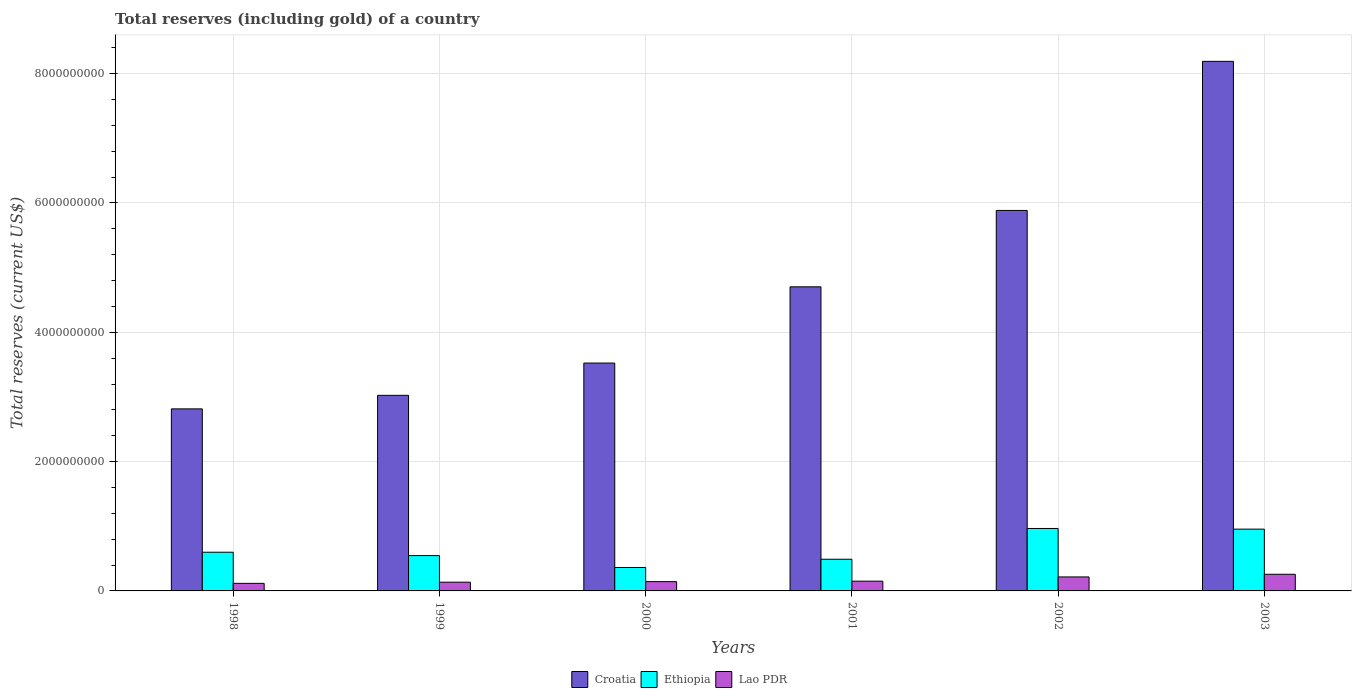How many different coloured bars are there?
Offer a terse response. 3. Are the number of bars per tick equal to the number of legend labels?
Give a very brief answer. Yes. What is the label of the 3rd group of bars from the left?
Give a very brief answer. 2000. What is the total reserves (including gold) in Croatia in 2003?
Your response must be concise. 8.19e+09. Across all years, what is the maximum total reserves (including gold) in Croatia?
Offer a very short reply. 8.19e+09. Across all years, what is the minimum total reserves (including gold) in Lao PDR?
Offer a terse response. 1.17e+08. In which year was the total reserves (including gold) in Lao PDR maximum?
Make the answer very short. 2003. In which year was the total reserves (including gold) in Croatia minimum?
Offer a very short reply. 1998. What is the total total reserves (including gold) in Ethiopia in the graph?
Your answer should be compact. 3.92e+09. What is the difference between the total reserves (including gold) in Croatia in 1999 and that in 2000?
Provide a short and direct response. -4.99e+08. What is the difference between the total reserves (including gold) in Croatia in 2000 and the total reserves (including gold) in Lao PDR in 2002?
Provide a succinct answer. 3.31e+09. What is the average total reserves (including gold) in Croatia per year?
Keep it short and to the point. 4.69e+09. In the year 2002, what is the difference between the total reserves (including gold) in Lao PDR and total reserves (including gold) in Croatia?
Provide a succinct answer. -5.67e+09. In how many years, is the total reserves (including gold) in Lao PDR greater than 3600000000 US$?
Make the answer very short. 0. What is the ratio of the total reserves (including gold) in Croatia in 1999 to that in 2000?
Your answer should be very brief. 0.86. Is the total reserves (including gold) in Croatia in 1999 less than that in 2000?
Offer a very short reply. Yes. Is the difference between the total reserves (including gold) in Lao PDR in 1998 and 2002 greater than the difference between the total reserves (including gold) in Croatia in 1998 and 2002?
Your response must be concise. Yes. What is the difference between the highest and the second highest total reserves (including gold) in Croatia?
Ensure brevity in your answer.  2.31e+09. What is the difference between the highest and the lowest total reserves (including gold) in Lao PDR?
Your response must be concise. 1.40e+08. Is the sum of the total reserves (including gold) in Lao PDR in 2002 and 2003 greater than the maximum total reserves (including gold) in Ethiopia across all years?
Make the answer very short. No. What does the 1st bar from the left in 1999 represents?
Make the answer very short. Croatia. What does the 2nd bar from the right in 1998 represents?
Make the answer very short. Ethiopia. Are all the bars in the graph horizontal?
Provide a short and direct response. No. How many years are there in the graph?
Provide a short and direct response. 6. What is the difference between two consecutive major ticks on the Y-axis?
Your response must be concise. 2.00e+09. Where does the legend appear in the graph?
Provide a succinct answer. Bottom center. How many legend labels are there?
Your answer should be very brief. 3. How are the legend labels stacked?
Keep it short and to the point. Horizontal. What is the title of the graph?
Offer a very short reply. Total reserves (including gold) of a country. What is the label or title of the X-axis?
Make the answer very short. Years. What is the label or title of the Y-axis?
Give a very brief answer. Total reserves (current US$). What is the Total reserves (current US$) in Croatia in 1998?
Give a very brief answer. 2.82e+09. What is the Total reserves (current US$) in Ethiopia in 1998?
Your answer should be very brief. 5.98e+08. What is the Total reserves (current US$) of Lao PDR in 1998?
Keep it short and to the point. 1.17e+08. What is the Total reserves (current US$) of Croatia in 1999?
Your response must be concise. 3.02e+09. What is the Total reserves (current US$) of Ethiopia in 1999?
Provide a succinct answer. 5.47e+08. What is the Total reserves (current US$) of Lao PDR in 1999?
Offer a terse response. 1.35e+08. What is the Total reserves (current US$) of Croatia in 2000?
Provide a short and direct response. 3.52e+09. What is the Total reserves (current US$) of Ethiopia in 2000?
Your answer should be very brief. 3.63e+08. What is the Total reserves (current US$) of Lao PDR in 2000?
Make the answer very short. 1.44e+08. What is the Total reserves (current US$) in Croatia in 2001?
Your answer should be compact. 4.70e+09. What is the Total reserves (current US$) in Ethiopia in 2001?
Keep it short and to the point. 4.90e+08. What is the Total reserves (current US$) of Lao PDR in 2001?
Offer a terse response. 1.51e+08. What is the Total reserves (current US$) of Croatia in 2002?
Offer a very short reply. 5.88e+09. What is the Total reserves (current US$) in Ethiopia in 2002?
Give a very brief answer. 9.66e+08. What is the Total reserves (current US$) in Lao PDR in 2002?
Your response must be concise. 2.16e+08. What is the Total reserves (current US$) of Croatia in 2003?
Provide a short and direct response. 8.19e+09. What is the Total reserves (current US$) of Ethiopia in 2003?
Ensure brevity in your answer.  9.56e+08. What is the Total reserves (current US$) in Lao PDR in 2003?
Keep it short and to the point. 2.57e+08. Across all years, what is the maximum Total reserves (current US$) in Croatia?
Your response must be concise. 8.19e+09. Across all years, what is the maximum Total reserves (current US$) of Ethiopia?
Offer a terse response. 9.66e+08. Across all years, what is the maximum Total reserves (current US$) of Lao PDR?
Provide a short and direct response. 2.57e+08. Across all years, what is the minimum Total reserves (current US$) of Croatia?
Ensure brevity in your answer.  2.82e+09. Across all years, what is the minimum Total reserves (current US$) in Ethiopia?
Your answer should be compact. 3.63e+08. Across all years, what is the minimum Total reserves (current US$) in Lao PDR?
Offer a terse response. 1.17e+08. What is the total Total reserves (current US$) in Croatia in the graph?
Offer a very short reply. 2.81e+1. What is the total Total reserves (current US$) in Ethiopia in the graph?
Provide a succinct answer. 3.92e+09. What is the total Total reserves (current US$) of Lao PDR in the graph?
Your answer should be compact. 1.02e+09. What is the difference between the Total reserves (current US$) of Croatia in 1998 and that in 1999?
Offer a terse response. -2.09e+08. What is the difference between the Total reserves (current US$) of Ethiopia in 1998 and that in 1999?
Your answer should be compact. 5.18e+07. What is the difference between the Total reserves (current US$) of Lao PDR in 1998 and that in 1999?
Your answer should be very brief. -1.80e+07. What is the difference between the Total reserves (current US$) of Croatia in 1998 and that in 2000?
Keep it short and to the point. -7.09e+08. What is the difference between the Total reserves (current US$) in Ethiopia in 1998 and that in 2000?
Provide a short and direct response. 2.36e+08. What is the difference between the Total reserves (current US$) in Lao PDR in 1998 and that in 2000?
Your response must be concise. -2.64e+07. What is the difference between the Total reserves (current US$) of Croatia in 1998 and that in 2001?
Offer a very short reply. -1.89e+09. What is the difference between the Total reserves (current US$) of Ethiopia in 1998 and that in 2001?
Provide a succinct answer. 1.09e+08. What is the difference between the Total reserves (current US$) of Lao PDR in 1998 and that in 2001?
Ensure brevity in your answer.  -3.38e+07. What is the difference between the Total reserves (current US$) of Croatia in 1998 and that in 2002?
Your response must be concise. -3.07e+09. What is the difference between the Total reserves (current US$) in Ethiopia in 1998 and that in 2002?
Make the answer very short. -3.67e+08. What is the difference between the Total reserves (current US$) of Lao PDR in 1998 and that in 2002?
Provide a short and direct response. -9.92e+07. What is the difference between the Total reserves (current US$) in Croatia in 1998 and that in 2003?
Provide a short and direct response. -5.37e+09. What is the difference between the Total reserves (current US$) in Ethiopia in 1998 and that in 2003?
Your answer should be compact. -3.57e+08. What is the difference between the Total reserves (current US$) of Lao PDR in 1998 and that in 2003?
Make the answer very short. -1.40e+08. What is the difference between the Total reserves (current US$) of Croatia in 1999 and that in 2000?
Your answer should be very brief. -4.99e+08. What is the difference between the Total reserves (current US$) of Ethiopia in 1999 and that in 2000?
Offer a very short reply. 1.84e+08. What is the difference between the Total reserves (current US$) in Lao PDR in 1999 and that in 2000?
Offer a very short reply. -8.41e+06. What is the difference between the Total reserves (current US$) in Croatia in 1999 and that in 2001?
Provide a short and direct response. -1.68e+09. What is the difference between the Total reserves (current US$) of Ethiopia in 1999 and that in 2001?
Ensure brevity in your answer.  5.67e+07. What is the difference between the Total reserves (current US$) of Lao PDR in 1999 and that in 2001?
Give a very brief answer. -1.57e+07. What is the difference between the Total reserves (current US$) in Croatia in 1999 and that in 2002?
Offer a very short reply. -2.86e+09. What is the difference between the Total reserves (current US$) of Ethiopia in 1999 and that in 2002?
Ensure brevity in your answer.  -4.19e+08. What is the difference between the Total reserves (current US$) in Lao PDR in 1999 and that in 2002?
Provide a succinct answer. -8.12e+07. What is the difference between the Total reserves (current US$) in Croatia in 1999 and that in 2003?
Offer a very short reply. -5.17e+09. What is the difference between the Total reserves (current US$) of Ethiopia in 1999 and that in 2003?
Keep it short and to the point. -4.09e+08. What is the difference between the Total reserves (current US$) in Lao PDR in 1999 and that in 2003?
Your answer should be very brief. -1.22e+08. What is the difference between the Total reserves (current US$) of Croatia in 2000 and that in 2001?
Your answer should be very brief. -1.18e+09. What is the difference between the Total reserves (current US$) of Ethiopia in 2000 and that in 2001?
Provide a short and direct response. -1.27e+08. What is the difference between the Total reserves (current US$) in Lao PDR in 2000 and that in 2001?
Offer a very short reply. -7.32e+06. What is the difference between the Total reserves (current US$) of Croatia in 2000 and that in 2002?
Your answer should be compact. -2.36e+09. What is the difference between the Total reserves (current US$) in Ethiopia in 2000 and that in 2002?
Provide a succinct answer. -6.03e+08. What is the difference between the Total reserves (current US$) in Lao PDR in 2000 and that in 2002?
Provide a short and direct response. -7.28e+07. What is the difference between the Total reserves (current US$) in Croatia in 2000 and that in 2003?
Your response must be concise. -4.67e+09. What is the difference between the Total reserves (current US$) of Ethiopia in 2000 and that in 2003?
Your answer should be compact. -5.93e+08. What is the difference between the Total reserves (current US$) of Lao PDR in 2000 and that in 2003?
Offer a very short reply. -1.14e+08. What is the difference between the Total reserves (current US$) of Croatia in 2001 and that in 2002?
Your answer should be compact. -1.18e+09. What is the difference between the Total reserves (current US$) in Ethiopia in 2001 and that in 2002?
Make the answer very short. -4.76e+08. What is the difference between the Total reserves (current US$) in Lao PDR in 2001 and that in 2002?
Your response must be concise. -6.54e+07. What is the difference between the Total reserves (current US$) of Croatia in 2001 and that in 2003?
Your response must be concise. -3.49e+09. What is the difference between the Total reserves (current US$) in Ethiopia in 2001 and that in 2003?
Offer a terse response. -4.66e+08. What is the difference between the Total reserves (current US$) of Lao PDR in 2001 and that in 2003?
Keep it short and to the point. -1.07e+08. What is the difference between the Total reserves (current US$) of Croatia in 2002 and that in 2003?
Give a very brief answer. -2.31e+09. What is the difference between the Total reserves (current US$) in Ethiopia in 2002 and that in 2003?
Provide a succinct answer. 1.03e+07. What is the difference between the Total reserves (current US$) in Lao PDR in 2002 and that in 2003?
Give a very brief answer. -4.11e+07. What is the difference between the Total reserves (current US$) of Croatia in 1998 and the Total reserves (current US$) of Ethiopia in 1999?
Your response must be concise. 2.27e+09. What is the difference between the Total reserves (current US$) in Croatia in 1998 and the Total reserves (current US$) in Lao PDR in 1999?
Your answer should be compact. 2.68e+09. What is the difference between the Total reserves (current US$) in Ethiopia in 1998 and the Total reserves (current US$) in Lao PDR in 1999?
Offer a very short reply. 4.63e+08. What is the difference between the Total reserves (current US$) in Croatia in 1998 and the Total reserves (current US$) in Ethiopia in 2000?
Keep it short and to the point. 2.45e+09. What is the difference between the Total reserves (current US$) in Croatia in 1998 and the Total reserves (current US$) in Lao PDR in 2000?
Make the answer very short. 2.67e+09. What is the difference between the Total reserves (current US$) of Ethiopia in 1998 and the Total reserves (current US$) of Lao PDR in 2000?
Give a very brief answer. 4.55e+08. What is the difference between the Total reserves (current US$) in Croatia in 1998 and the Total reserves (current US$) in Ethiopia in 2001?
Your answer should be very brief. 2.33e+09. What is the difference between the Total reserves (current US$) in Croatia in 1998 and the Total reserves (current US$) in Lao PDR in 2001?
Make the answer very short. 2.66e+09. What is the difference between the Total reserves (current US$) of Ethiopia in 1998 and the Total reserves (current US$) of Lao PDR in 2001?
Ensure brevity in your answer.  4.47e+08. What is the difference between the Total reserves (current US$) in Croatia in 1998 and the Total reserves (current US$) in Ethiopia in 2002?
Your answer should be compact. 1.85e+09. What is the difference between the Total reserves (current US$) in Croatia in 1998 and the Total reserves (current US$) in Lao PDR in 2002?
Your response must be concise. 2.60e+09. What is the difference between the Total reserves (current US$) in Ethiopia in 1998 and the Total reserves (current US$) in Lao PDR in 2002?
Offer a terse response. 3.82e+08. What is the difference between the Total reserves (current US$) of Croatia in 1998 and the Total reserves (current US$) of Ethiopia in 2003?
Give a very brief answer. 1.86e+09. What is the difference between the Total reserves (current US$) in Croatia in 1998 and the Total reserves (current US$) in Lao PDR in 2003?
Provide a succinct answer. 2.56e+09. What is the difference between the Total reserves (current US$) in Ethiopia in 1998 and the Total reserves (current US$) in Lao PDR in 2003?
Give a very brief answer. 3.41e+08. What is the difference between the Total reserves (current US$) in Croatia in 1999 and the Total reserves (current US$) in Ethiopia in 2000?
Provide a short and direct response. 2.66e+09. What is the difference between the Total reserves (current US$) in Croatia in 1999 and the Total reserves (current US$) in Lao PDR in 2000?
Ensure brevity in your answer.  2.88e+09. What is the difference between the Total reserves (current US$) of Ethiopia in 1999 and the Total reserves (current US$) of Lao PDR in 2000?
Ensure brevity in your answer.  4.03e+08. What is the difference between the Total reserves (current US$) of Croatia in 1999 and the Total reserves (current US$) of Ethiopia in 2001?
Ensure brevity in your answer.  2.54e+09. What is the difference between the Total reserves (current US$) in Croatia in 1999 and the Total reserves (current US$) in Lao PDR in 2001?
Provide a short and direct response. 2.87e+09. What is the difference between the Total reserves (current US$) in Ethiopia in 1999 and the Total reserves (current US$) in Lao PDR in 2001?
Give a very brief answer. 3.96e+08. What is the difference between the Total reserves (current US$) in Croatia in 1999 and the Total reserves (current US$) in Ethiopia in 2002?
Give a very brief answer. 2.06e+09. What is the difference between the Total reserves (current US$) of Croatia in 1999 and the Total reserves (current US$) of Lao PDR in 2002?
Provide a short and direct response. 2.81e+09. What is the difference between the Total reserves (current US$) of Ethiopia in 1999 and the Total reserves (current US$) of Lao PDR in 2002?
Keep it short and to the point. 3.30e+08. What is the difference between the Total reserves (current US$) of Croatia in 1999 and the Total reserves (current US$) of Ethiopia in 2003?
Your answer should be very brief. 2.07e+09. What is the difference between the Total reserves (current US$) of Croatia in 1999 and the Total reserves (current US$) of Lao PDR in 2003?
Offer a very short reply. 2.77e+09. What is the difference between the Total reserves (current US$) of Ethiopia in 1999 and the Total reserves (current US$) of Lao PDR in 2003?
Give a very brief answer. 2.89e+08. What is the difference between the Total reserves (current US$) in Croatia in 2000 and the Total reserves (current US$) in Ethiopia in 2001?
Your answer should be very brief. 3.03e+09. What is the difference between the Total reserves (current US$) in Croatia in 2000 and the Total reserves (current US$) in Lao PDR in 2001?
Your answer should be compact. 3.37e+09. What is the difference between the Total reserves (current US$) of Ethiopia in 2000 and the Total reserves (current US$) of Lao PDR in 2001?
Give a very brief answer. 2.12e+08. What is the difference between the Total reserves (current US$) of Croatia in 2000 and the Total reserves (current US$) of Ethiopia in 2002?
Provide a succinct answer. 2.56e+09. What is the difference between the Total reserves (current US$) in Croatia in 2000 and the Total reserves (current US$) in Lao PDR in 2002?
Provide a short and direct response. 3.31e+09. What is the difference between the Total reserves (current US$) of Ethiopia in 2000 and the Total reserves (current US$) of Lao PDR in 2002?
Your answer should be very brief. 1.46e+08. What is the difference between the Total reserves (current US$) of Croatia in 2000 and the Total reserves (current US$) of Ethiopia in 2003?
Your response must be concise. 2.57e+09. What is the difference between the Total reserves (current US$) in Croatia in 2000 and the Total reserves (current US$) in Lao PDR in 2003?
Your response must be concise. 3.27e+09. What is the difference between the Total reserves (current US$) in Ethiopia in 2000 and the Total reserves (current US$) in Lao PDR in 2003?
Keep it short and to the point. 1.05e+08. What is the difference between the Total reserves (current US$) in Croatia in 2001 and the Total reserves (current US$) in Ethiopia in 2002?
Make the answer very short. 3.74e+09. What is the difference between the Total reserves (current US$) in Croatia in 2001 and the Total reserves (current US$) in Lao PDR in 2002?
Keep it short and to the point. 4.49e+09. What is the difference between the Total reserves (current US$) of Ethiopia in 2001 and the Total reserves (current US$) of Lao PDR in 2002?
Keep it short and to the point. 2.74e+08. What is the difference between the Total reserves (current US$) in Croatia in 2001 and the Total reserves (current US$) in Ethiopia in 2003?
Your answer should be compact. 3.75e+09. What is the difference between the Total reserves (current US$) of Croatia in 2001 and the Total reserves (current US$) of Lao PDR in 2003?
Keep it short and to the point. 4.45e+09. What is the difference between the Total reserves (current US$) in Ethiopia in 2001 and the Total reserves (current US$) in Lao PDR in 2003?
Provide a short and direct response. 2.32e+08. What is the difference between the Total reserves (current US$) of Croatia in 2002 and the Total reserves (current US$) of Ethiopia in 2003?
Offer a terse response. 4.93e+09. What is the difference between the Total reserves (current US$) of Croatia in 2002 and the Total reserves (current US$) of Lao PDR in 2003?
Your answer should be very brief. 5.63e+09. What is the difference between the Total reserves (current US$) of Ethiopia in 2002 and the Total reserves (current US$) of Lao PDR in 2003?
Keep it short and to the point. 7.08e+08. What is the average Total reserves (current US$) in Croatia per year?
Give a very brief answer. 4.69e+09. What is the average Total reserves (current US$) of Ethiopia per year?
Offer a terse response. 6.53e+08. What is the average Total reserves (current US$) of Lao PDR per year?
Your response must be concise. 1.70e+08. In the year 1998, what is the difference between the Total reserves (current US$) in Croatia and Total reserves (current US$) in Ethiopia?
Provide a short and direct response. 2.22e+09. In the year 1998, what is the difference between the Total reserves (current US$) of Croatia and Total reserves (current US$) of Lao PDR?
Your answer should be very brief. 2.70e+09. In the year 1998, what is the difference between the Total reserves (current US$) in Ethiopia and Total reserves (current US$) in Lao PDR?
Provide a short and direct response. 4.81e+08. In the year 1999, what is the difference between the Total reserves (current US$) in Croatia and Total reserves (current US$) in Ethiopia?
Your response must be concise. 2.48e+09. In the year 1999, what is the difference between the Total reserves (current US$) in Croatia and Total reserves (current US$) in Lao PDR?
Ensure brevity in your answer.  2.89e+09. In the year 1999, what is the difference between the Total reserves (current US$) of Ethiopia and Total reserves (current US$) of Lao PDR?
Offer a terse response. 4.11e+08. In the year 2000, what is the difference between the Total reserves (current US$) in Croatia and Total reserves (current US$) in Ethiopia?
Provide a succinct answer. 3.16e+09. In the year 2000, what is the difference between the Total reserves (current US$) in Croatia and Total reserves (current US$) in Lao PDR?
Offer a terse response. 3.38e+09. In the year 2000, what is the difference between the Total reserves (current US$) in Ethiopia and Total reserves (current US$) in Lao PDR?
Ensure brevity in your answer.  2.19e+08. In the year 2001, what is the difference between the Total reserves (current US$) of Croatia and Total reserves (current US$) of Ethiopia?
Provide a succinct answer. 4.21e+09. In the year 2001, what is the difference between the Total reserves (current US$) in Croatia and Total reserves (current US$) in Lao PDR?
Your response must be concise. 4.55e+09. In the year 2001, what is the difference between the Total reserves (current US$) in Ethiopia and Total reserves (current US$) in Lao PDR?
Your response must be concise. 3.39e+08. In the year 2002, what is the difference between the Total reserves (current US$) in Croatia and Total reserves (current US$) in Ethiopia?
Offer a terse response. 4.92e+09. In the year 2002, what is the difference between the Total reserves (current US$) in Croatia and Total reserves (current US$) in Lao PDR?
Offer a very short reply. 5.67e+09. In the year 2002, what is the difference between the Total reserves (current US$) in Ethiopia and Total reserves (current US$) in Lao PDR?
Make the answer very short. 7.50e+08. In the year 2003, what is the difference between the Total reserves (current US$) in Croatia and Total reserves (current US$) in Ethiopia?
Your answer should be very brief. 7.23e+09. In the year 2003, what is the difference between the Total reserves (current US$) of Croatia and Total reserves (current US$) of Lao PDR?
Keep it short and to the point. 7.93e+09. In the year 2003, what is the difference between the Total reserves (current US$) in Ethiopia and Total reserves (current US$) in Lao PDR?
Make the answer very short. 6.98e+08. What is the ratio of the Total reserves (current US$) of Croatia in 1998 to that in 1999?
Offer a terse response. 0.93. What is the ratio of the Total reserves (current US$) of Ethiopia in 1998 to that in 1999?
Your answer should be very brief. 1.09. What is the ratio of the Total reserves (current US$) in Lao PDR in 1998 to that in 1999?
Offer a terse response. 0.87. What is the ratio of the Total reserves (current US$) in Croatia in 1998 to that in 2000?
Your response must be concise. 0.8. What is the ratio of the Total reserves (current US$) of Ethiopia in 1998 to that in 2000?
Your answer should be very brief. 1.65. What is the ratio of the Total reserves (current US$) of Lao PDR in 1998 to that in 2000?
Your answer should be compact. 0.82. What is the ratio of the Total reserves (current US$) of Croatia in 1998 to that in 2001?
Offer a very short reply. 0.6. What is the ratio of the Total reserves (current US$) in Ethiopia in 1998 to that in 2001?
Make the answer very short. 1.22. What is the ratio of the Total reserves (current US$) in Lao PDR in 1998 to that in 2001?
Provide a short and direct response. 0.78. What is the ratio of the Total reserves (current US$) in Croatia in 1998 to that in 2002?
Offer a very short reply. 0.48. What is the ratio of the Total reserves (current US$) of Ethiopia in 1998 to that in 2002?
Provide a succinct answer. 0.62. What is the ratio of the Total reserves (current US$) in Lao PDR in 1998 to that in 2002?
Make the answer very short. 0.54. What is the ratio of the Total reserves (current US$) in Croatia in 1998 to that in 2003?
Give a very brief answer. 0.34. What is the ratio of the Total reserves (current US$) in Ethiopia in 1998 to that in 2003?
Offer a very short reply. 0.63. What is the ratio of the Total reserves (current US$) of Lao PDR in 1998 to that in 2003?
Your answer should be very brief. 0.46. What is the ratio of the Total reserves (current US$) in Croatia in 1999 to that in 2000?
Provide a succinct answer. 0.86. What is the ratio of the Total reserves (current US$) in Ethiopia in 1999 to that in 2000?
Provide a short and direct response. 1.51. What is the ratio of the Total reserves (current US$) in Lao PDR in 1999 to that in 2000?
Ensure brevity in your answer.  0.94. What is the ratio of the Total reserves (current US$) of Croatia in 1999 to that in 2001?
Provide a short and direct response. 0.64. What is the ratio of the Total reserves (current US$) of Ethiopia in 1999 to that in 2001?
Your answer should be very brief. 1.12. What is the ratio of the Total reserves (current US$) of Lao PDR in 1999 to that in 2001?
Give a very brief answer. 0.9. What is the ratio of the Total reserves (current US$) in Croatia in 1999 to that in 2002?
Your answer should be very brief. 0.51. What is the ratio of the Total reserves (current US$) of Ethiopia in 1999 to that in 2002?
Offer a very short reply. 0.57. What is the ratio of the Total reserves (current US$) of Lao PDR in 1999 to that in 2002?
Ensure brevity in your answer.  0.62. What is the ratio of the Total reserves (current US$) in Croatia in 1999 to that in 2003?
Provide a succinct answer. 0.37. What is the ratio of the Total reserves (current US$) in Ethiopia in 1999 to that in 2003?
Offer a very short reply. 0.57. What is the ratio of the Total reserves (current US$) of Lao PDR in 1999 to that in 2003?
Your response must be concise. 0.53. What is the ratio of the Total reserves (current US$) in Croatia in 2000 to that in 2001?
Make the answer very short. 0.75. What is the ratio of the Total reserves (current US$) of Ethiopia in 2000 to that in 2001?
Give a very brief answer. 0.74. What is the ratio of the Total reserves (current US$) in Lao PDR in 2000 to that in 2001?
Your answer should be compact. 0.95. What is the ratio of the Total reserves (current US$) of Croatia in 2000 to that in 2002?
Keep it short and to the point. 0.6. What is the ratio of the Total reserves (current US$) of Ethiopia in 2000 to that in 2002?
Your answer should be compact. 0.38. What is the ratio of the Total reserves (current US$) of Lao PDR in 2000 to that in 2002?
Offer a very short reply. 0.66. What is the ratio of the Total reserves (current US$) of Croatia in 2000 to that in 2003?
Your response must be concise. 0.43. What is the ratio of the Total reserves (current US$) in Ethiopia in 2000 to that in 2003?
Ensure brevity in your answer.  0.38. What is the ratio of the Total reserves (current US$) of Lao PDR in 2000 to that in 2003?
Make the answer very short. 0.56. What is the ratio of the Total reserves (current US$) in Croatia in 2001 to that in 2002?
Your response must be concise. 0.8. What is the ratio of the Total reserves (current US$) of Ethiopia in 2001 to that in 2002?
Your response must be concise. 0.51. What is the ratio of the Total reserves (current US$) in Lao PDR in 2001 to that in 2002?
Your answer should be very brief. 0.7. What is the ratio of the Total reserves (current US$) of Croatia in 2001 to that in 2003?
Provide a short and direct response. 0.57. What is the ratio of the Total reserves (current US$) of Ethiopia in 2001 to that in 2003?
Your response must be concise. 0.51. What is the ratio of the Total reserves (current US$) of Lao PDR in 2001 to that in 2003?
Offer a terse response. 0.59. What is the ratio of the Total reserves (current US$) of Croatia in 2002 to that in 2003?
Offer a terse response. 0.72. What is the ratio of the Total reserves (current US$) of Ethiopia in 2002 to that in 2003?
Your response must be concise. 1.01. What is the ratio of the Total reserves (current US$) in Lao PDR in 2002 to that in 2003?
Make the answer very short. 0.84. What is the difference between the highest and the second highest Total reserves (current US$) in Croatia?
Provide a succinct answer. 2.31e+09. What is the difference between the highest and the second highest Total reserves (current US$) in Ethiopia?
Your answer should be very brief. 1.03e+07. What is the difference between the highest and the second highest Total reserves (current US$) of Lao PDR?
Offer a terse response. 4.11e+07. What is the difference between the highest and the lowest Total reserves (current US$) of Croatia?
Ensure brevity in your answer.  5.37e+09. What is the difference between the highest and the lowest Total reserves (current US$) of Ethiopia?
Offer a very short reply. 6.03e+08. What is the difference between the highest and the lowest Total reserves (current US$) in Lao PDR?
Give a very brief answer. 1.40e+08. 